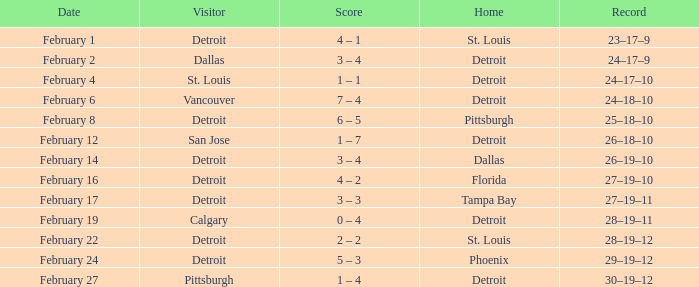What was their record on February 24? 29–19–12. 